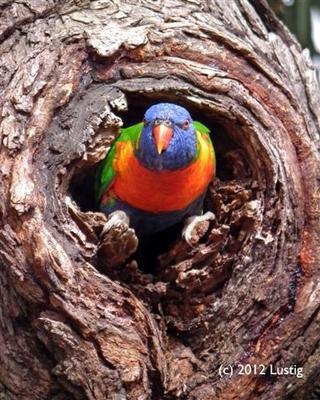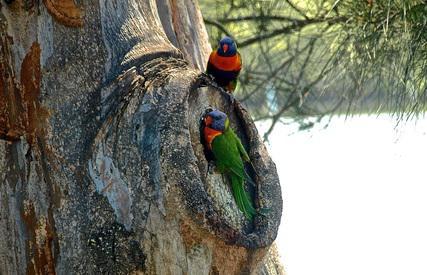The first image is the image on the left, the second image is the image on the right. Assess this claim about the two images: "The right image contains at least three parrots.". Correct or not? Answer yes or no. No. The first image is the image on the left, the second image is the image on the right. Assess this claim about the two images: "Left and right images each show no more than two birds, and all images show a bird near a hollow in a tree.". Correct or not? Answer yes or no. Yes. 